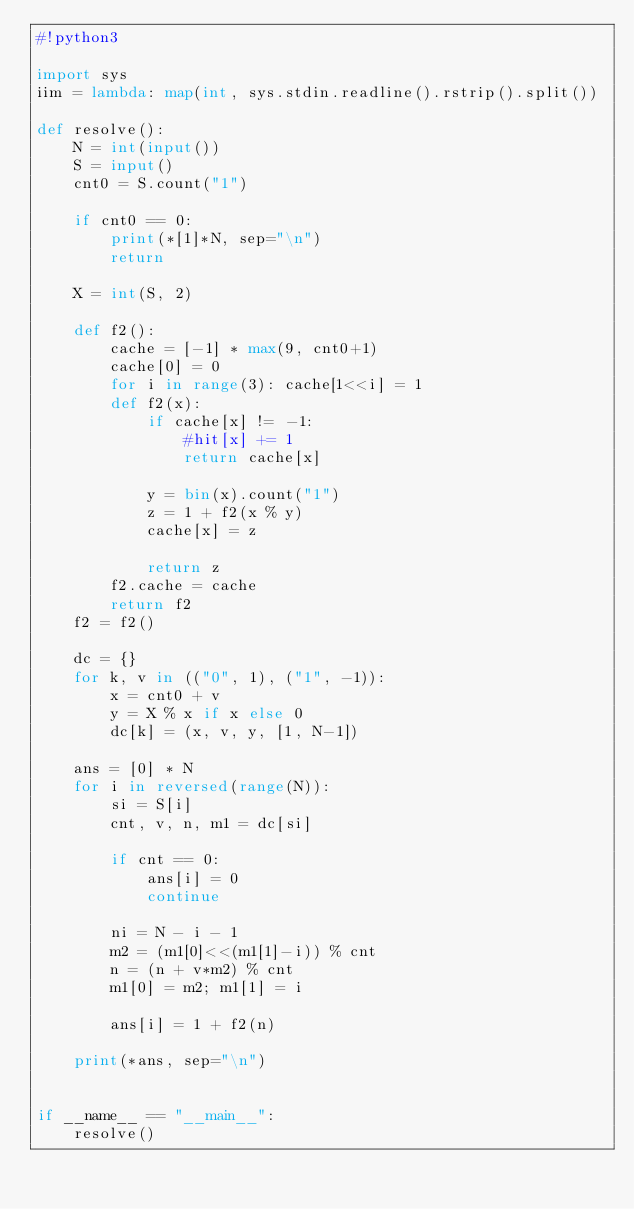<code> <loc_0><loc_0><loc_500><loc_500><_Python_>#!python3

import sys
iim = lambda: map(int, sys.stdin.readline().rstrip().split())

def resolve():
    N = int(input())
    S = input()
    cnt0 = S.count("1")

    if cnt0 == 0:
        print(*[1]*N, sep="\n")
        return

    X = int(S, 2)

    def f2():
        cache = [-1] * max(9, cnt0+1)
        cache[0] = 0
        for i in range(3): cache[1<<i] = 1
        def f2(x):
            if cache[x] != -1:
                #hit[x] += 1
                return cache[x]

            y = bin(x).count("1")
            z = 1 + f2(x % y)
            cache[x] = z

            return z
        f2.cache = cache
        return f2
    f2 = f2()

    dc = {}
    for k, v in (("0", 1), ("1", -1)):
        x = cnt0 + v
        y = X % x if x else 0
        dc[k] = (x, v, y, [1, N-1])

    ans = [0] * N
    for i in reversed(range(N)):
        si = S[i]
        cnt, v, n, m1 = dc[si]

        if cnt == 0:
            ans[i] = 0
            continue

        ni = N - i - 1
        m2 = (m1[0]<<(m1[1]-i)) % cnt
        n = (n + v*m2) % cnt
        m1[0] = m2; m1[1] = i

        ans[i] = 1 + f2(n)

    print(*ans, sep="\n")


if __name__ == "__main__":
    resolve()
</code> 